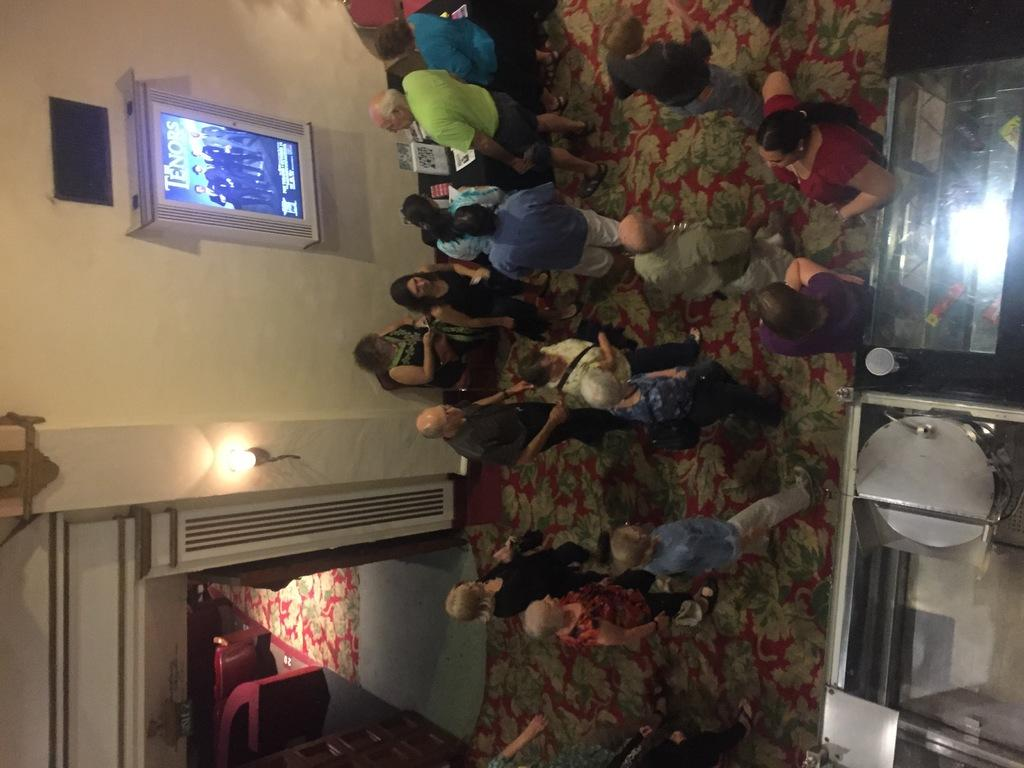What is happening in the image? There are people standing in the image. Can you describe any objects in the image? There is a light and a screen in the image. What is being displayed on the screen? There are people in black dress visible on the screen. What type of fold can be seen in the image? There is no fold present in the image. What material is the cable made of in the image? There is no cable present in the image. 